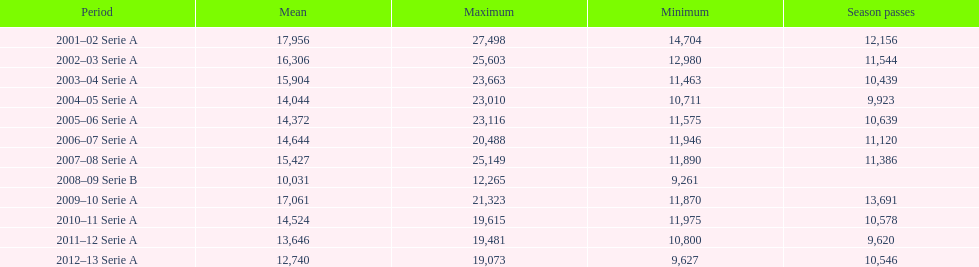What was the average in 2001 17,956. 